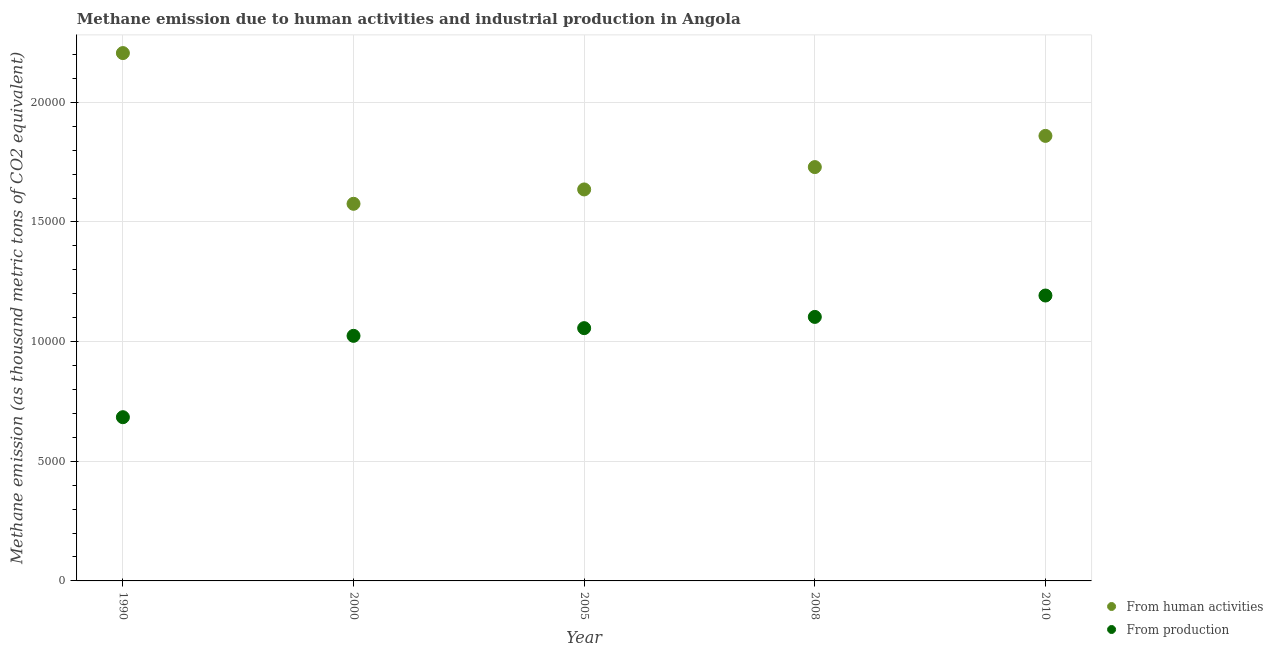What is the amount of emissions from human activities in 2000?
Your answer should be compact. 1.58e+04. Across all years, what is the maximum amount of emissions from human activities?
Provide a succinct answer. 2.21e+04. Across all years, what is the minimum amount of emissions generated from industries?
Your answer should be very brief. 6841.7. In which year was the amount of emissions from human activities maximum?
Your answer should be compact. 1990. What is the total amount of emissions from human activities in the graph?
Ensure brevity in your answer.  9.01e+04. What is the difference between the amount of emissions generated from industries in 1990 and that in 2000?
Offer a terse response. -3399.1. What is the difference between the amount of emissions from human activities in 1990 and the amount of emissions generated from industries in 2005?
Your response must be concise. 1.15e+04. What is the average amount of emissions generated from industries per year?
Keep it short and to the point. 1.01e+04. In the year 2008, what is the difference between the amount of emissions from human activities and amount of emissions generated from industries?
Give a very brief answer. 6260.9. In how many years, is the amount of emissions generated from industries greater than 14000 thousand metric tons?
Offer a terse response. 0. What is the ratio of the amount of emissions from human activities in 2008 to that in 2010?
Offer a terse response. 0.93. What is the difference between the highest and the second highest amount of emissions generated from industries?
Provide a short and direct response. 894.1. What is the difference between the highest and the lowest amount of emissions generated from industries?
Your response must be concise. 5084.3. Does the amount of emissions from human activities monotonically increase over the years?
Make the answer very short. No. Is the amount of emissions from human activities strictly less than the amount of emissions generated from industries over the years?
Offer a terse response. No. Does the graph contain any zero values?
Offer a terse response. No. Does the graph contain grids?
Your answer should be very brief. Yes. How are the legend labels stacked?
Offer a very short reply. Vertical. What is the title of the graph?
Keep it short and to the point. Methane emission due to human activities and industrial production in Angola. What is the label or title of the X-axis?
Provide a succinct answer. Year. What is the label or title of the Y-axis?
Your response must be concise. Methane emission (as thousand metric tons of CO2 equivalent). What is the Methane emission (as thousand metric tons of CO2 equivalent) in From human activities in 1990?
Provide a short and direct response. 2.21e+04. What is the Methane emission (as thousand metric tons of CO2 equivalent) in From production in 1990?
Make the answer very short. 6841.7. What is the Methane emission (as thousand metric tons of CO2 equivalent) in From human activities in 2000?
Provide a short and direct response. 1.58e+04. What is the Methane emission (as thousand metric tons of CO2 equivalent) of From production in 2000?
Your response must be concise. 1.02e+04. What is the Methane emission (as thousand metric tons of CO2 equivalent) in From human activities in 2005?
Provide a short and direct response. 1.64e+04. What is the Methane emission (as thousand metric tons of CO2 equivalent) of From production in 2005?
Provide a succinct answer. 1.06e+04. What is the Methane emission (as thousand metric tons of CO2 equivalent) in From human activities in 2008?
Make the answer very short. 1.73e+04. What is the Methane emission (as thousand metric tons of CO2 equivalent) in From production in 2008?
Offer a very short reply. 1.10e+04. What is the Methane emission (as thousand metric tons of CO2 equivalent) in From human activities in 2010?
Give a very brief answer. 1.86e+04. What is the Methane emission (as thousand metric tons of CO2 equivalent) of From production in 2010?
Offer a very short reply. 1.19e+04. Across all years, what is the maximum Methane emission (as thousand metric tons of CO2 equivalent) in From human activities?
Provide a short and direct response. 2.21e+04. Across all years, what is the maximum Methane emission (as thousand metric tons of CO2 equivalent) in From production?
Offer a very short reply. 1.19e+04. Across all years, what is the minimum Methane emission (as thousand metric tons of CO2 equivalent) of From human activities?
Your answer should be very brief. 1.58e+04. Across all years, what is the minimum Methane emission (as thousand metric tons of CO2 equivalent) of From production?
Provide a short and direct response. 6841.7. What is the total Methane emission (as thousand metric tons of CO2 equivalent) in From human activities in the graph?
Offer a very short reply. 9.01e+04. What is the total Methane emission (as thousand metric tons of CO2 equivalent) of From production in the graph?
Your answer should be very brief. 5.06e+04. What is the difference between the Methane emission (as thousand metric tons of CO2 equivalent) in From human activities in 1990 and that in 2000?
Give a very brief answer. 6298. What is the difference between the Methane emission (as thousand metric tons of CO2 equivalent) of From production in 1990 and that in 2000?
Make the answer very short. -3399.1. What is the difference between the Methane emission (as thousand metric tons of CO2 equivalent) of From human activities in 1990 and that in 2005?
Provide a short and direct response. 5697.9. What is the difference between the Methane emission (as thousand metric tons of CO2 equivalent) of From production in 1990 and that in 2005?
Your response must be concise. -3720.7. What is the difference between the Methane emission (as thousand metric tons of CO2 equivalent) in From human activities in 1990 and that in 2008?
Ensure brevity in your answer.  4763.8. What is the difference between the Methane emission (as thousand metric tons of CO2 equivalent) in From production in 1990 and that in 2008?
Make the answer very short. -4190.2. What is the difference between the Methane emission (as thousand metric tons of CO2 equivalent) in From human activities in 1990 and that in 2010?
Keep it short and to the point. 3460.1. What is the difference between the Methane emission (as thousand metric tons of CO2 equivalent) in From production in 1990 and that in 2010?
Your answer should be compact. -5084.3. What is the difference between the Methane emission (as thousand metric tons of CO2 equivalent) in From human activities in 2000 and that in 2005?
Offer a terse response. -600.1. What is the difference between the Methane emission (as thousand metric tons of CO2 equivalent) in From production in 2000 and that in 2005?
Offer a very short reply. -321.6. What is the difference between the Methane emission (as thousand metric tons of CO2 equivalent) of From human activities in 2000 and that in 2008?
Ensure brevity in your answer.  -1534.2. What is the difference between the Methane emission (as thousand metric tons of CO2 equivalent) of From production in 2000 and that in 2008?
Make the answer very short. -791.1. What is the difference between the Methane emission (as thousand metric tons of CO2 equivalent) of From human activities in 2000 and that in 2010?
Offer a terse response. -2837.9. What is the difference between the Methane emission (as thousand metric tons of CO2 equivalent) of From production in 2000 and that in 2010?
Provide a short and direct response. -1685.2. What is the difference between the Methane emission (as thousand metric tons of CO2 equivalent) in From human activities in 2005 and that in 2008?
Provide a short and direct response. -934.1. What is the difference between the Methane emission (as thousand metric tons of CO2 equivalent) in From production in 2005 and that in 2008?
Your answer should be very brief. -469.5. What is the difference between the Methane emission (as thousand metric tons of CO2 equivalent) in From human activities in 2005 and that in 2010?
Provide a succinct answer. -2237.8. What is the difference between the Methane emission (as thousand metric tons of CO2 equivalent) of From production in 2005 and that in 2010?
Give a very brief answer. -1363.6. What is the difference between the Methane emission (as thousand metric tons of CO2 equivalent) in From human activities in 2008 and that in 2010?
Ensure brevity in your answer.  -1303.7. What is the difference between the Methane emission (as thousand metric tons of CO2 equivalent) in From production in 2008 and that in 2010?
Your answer should be compact. -894.1. What is the difference between the Methane emission (as thousand metric tons of CO2 equivalent) in From human activities in 1990 and the Methane emission (as thousand metric tons of CO2 equivalent) in From production in 2000?
Give a very brief answer. 1.18e+04. What is the difference between the Methane emission (as thousand metric tons of CO2 equivalent) of From human activities in 1990 and the Methane emission (as thousand metric tons of CO2 equivalent) of From production in 2005?
Ensure brevity in your answer.  1.15e+04. What is the difference between the Methane emission (as thousand metric tons of CO2 equivalent) of From human activities in 1990 and the Methane emission (as thousand metric tons of CO2 equivalent) of From production in 2008?
Ensure brevity in your answer.  1.10e+04. What is the difference between the Methane emission (as thousand metric tons of CO2 equivalent) in From human activities in 1990 and the Methane emission (as thousand metric tons of CO2 equivalent) in From production in 2010?
Provide a succinct answer. 1.01e+04. What is the difference between the Methane emission (as thousand metric tons of CO2 equivalent) of From human activities in 2000 and the Methane emission (as thousand metric tons of CO2 equivalent) of From production in 2005?
Offer a very short reply. 5196.2. What is the difference between the Methane emission (as thousand metric tons of CO2 equivalent) of From human activities in 2000 and the Methane emission (as thousand metric tons of CO2 equivalent) of From production in 2008?
Provide a short and direct response. 4726.7. What is the difference between the Methane emission (as thousand metric tons of CO2 equivalent) of From human activities in 2000 and the Methane emission (as thousand metric tons of CO2 equivalent) of From production in 2010?
Your answer should be compact. 3832.6. What is the difference between the Methane emission (as thousand metric tons of CO2 equivalent) of From human activities in 2005 and the Methane emission (as thousand metric tons of CO2 equivalent) of From production in 2008?
Your answer should be very brief. 5326.8. What is the difference between the Methane emission (as thousand metric tons of CO2 equivalent) in From human activities in 2005 and the Methane emission (as thousand metric tons of CO2 equivalent) in From production in 2010?
Provide a succinct answer. 4432.7. What is the difference between the Methane emission (as thousand metric tons of CO2 equivalent) in From human activities in 2008 and the Methane emission (as thousand metric tons of CO2 equivalent) in From production in 2010?
Offer a very short reply. 5366.8. What is the average Methane emission (as thousand metric tons of CO2 equivalent) in From human activities per year?
Keep it short and to the point. 1.80e+04. What is the average Methane emission (as thousand metric tons of CO2 equivalent) in From production per year?
Your answer should be very brief. 1.01e+04. In the year 1990, what is the difference between the Methane emission (as thousand metric tons of CO2 equivalent) of From human activities and Methane emission (as thousand metric tons of CO2 equivalent) of From production?
Offer a very short reply. 1.52e+04. In the year 2000, what is the difference between the Methane emission (as thousand metric tons of CO2 equivalent) of From human activities and Methane emission (as thousand metric tons of CO2 equivalent) of From production?
Provide a short and direct response. 5517.8. In the year 2005, what is the difference between the Methane emission (as thousand metric tons of CO2 equivalent) in From human activities and Methane emission (as thousand metric tons of CO2 equivalent) in From production?
Ensure brevity in your answer.  5796.3. In the year 2008, what is the difference between the Methane emission (as thousand metric tons of CO2 equivalent) in From human activities and Methane emission (as thousand metric tons of CO2 equivalent) in From production?
Make the answer very short. 6260.9. In the year 2010, what is the difference between the Methane emission (as thousand metric tons of CO2 equivalent) of From human activities and Methane emission (as thousand metric tons of CO2 equivalent) of From production?
Your response must be concise. 6670.5. What is the ratio of the Methane emission (as thousand metric tons of CO2 equivalent) in From human activities in 1990 to that in 2000?
Your response must be concise. 1.4. What is the ratio of the Methane emission (as thousand metric tons of CO2 equivalent) in From production in 1990 to that in 2000?
Your answer should be compact. 0.67. What is the ratio of the Methane emission (as thousand metric tons of CO2 equivalent) in From human activities in 1990 to that in 2005?
Offer a terse response. 1.35. What is the ratio of the Methane emission (as thousand metric tons of CO2 equivalent) of From production in 1990 to that in 2005?
Provide a short and direct response. 0.65. What is the ratio of the Methane emission (as thousand metric tons of CO2 equivalent) of From human activities in 1990 to that in 2008?
Keep it short and to the point. 1.28. What is the ratio of the Methane emission (as thousand metric tons of CO2 equivalent) in From production in 1990 to that in 2008?
Offer a terse response. 0.62. What is the ratio of the Methane emission (as thousand metric tons of CO2 equivalent) of From human activities in 1990 to that in 2010?
Ensure brevity in your answer.  1.19. What is the ratio of the Methane emission (as thousand metric tons of CO2 equivalent) of From production in 1990 to that in 2010?
Make the answer very short. 0.57. What is the ratio of the Methane emission (as thousand metric tons of CO2 equivalent) in From human activities in 2000 to that in 2005?
Your response must be concise. 0.96. What is the ratio of the Methane emission (as thousand metric tons of CO2 equivalent) of From production in 2000 to that in 2005?
Ensure brevity in your answer.  0.97. What is the ratio of the Methane emission (as thousand metric tons of CO2 equivalent) of From human activities in 2000 to that in 2008?
Keep it short and to the point. 0.91. What is the ratio of the Methane emission (as thousand metric tons of CO2 equivalent) in From production in 2000 to that in 2008?
Your response must be concise. 0.93. What is the ratio of the Methane emission (as thousand metric tons of CO2 equivalent) in From human activities in 2000 to that in 2010?
Ensure brevity in your answer.  0.85. What is the ratio of the Methane emission (as thousand metric tons of CO2 equivalent) in From production in 2000 to that in 2010?
Make the answer very short. 0.86. What is the ratio of the Methane emission (as thousand metric tons of CO2 equivalent) in From human activities in 2005 to that in 2008?
Your answer should be very brief. 0.95. What is the ratio of the Methane emission (as thousand metric tons of CO2 equivalent) in From production in 2005 to that in 2008?
Your answer should be very brief. 0.96. What is the ratio of the Methane emission (as thousand metric tons of CO2 equivalent) of From human activities in 2005 to that in 2010?
Keep it short and to the point. 0.88. What is the ratio of the Methane emission (as thousand metric tons of CO2 equivalent) in From production in 2005 to that in 2010?
Your answer should be very brief. 0.89. What is the ratio of the Methane emission (as thousand metric tons of CO2 equivalent) of From human activities in 2008 to that in 2010?
Give a very brief answer. 0.93. What is the ratio of the Methane emission (as thousand metric tons of CO2 equivalent) of From production in 2008 to that in 2010?
Offer a terse response. 0.93. What is the difference between the highest and the second highest Methane emission (as thousand metric tons of CO2 equivalent) of From human activities?
Offer a terse response. 3460.1. What is the difference between the highest and the second highest Methane emission (as thousand metric tons of CO2 equivalent) of From production?
Offer a terse response. 894.1. What is the difference between the highest and the lowest Methane emission (as thousand metric tons of CO2 equivalent) in From human activities?
Make the answer very short. 6298. What is the difference between the highest and the lowest Methane emission (as thousand metric tons of CO2 equivalent) in From production?
Make the answer very short. 5084.3. 